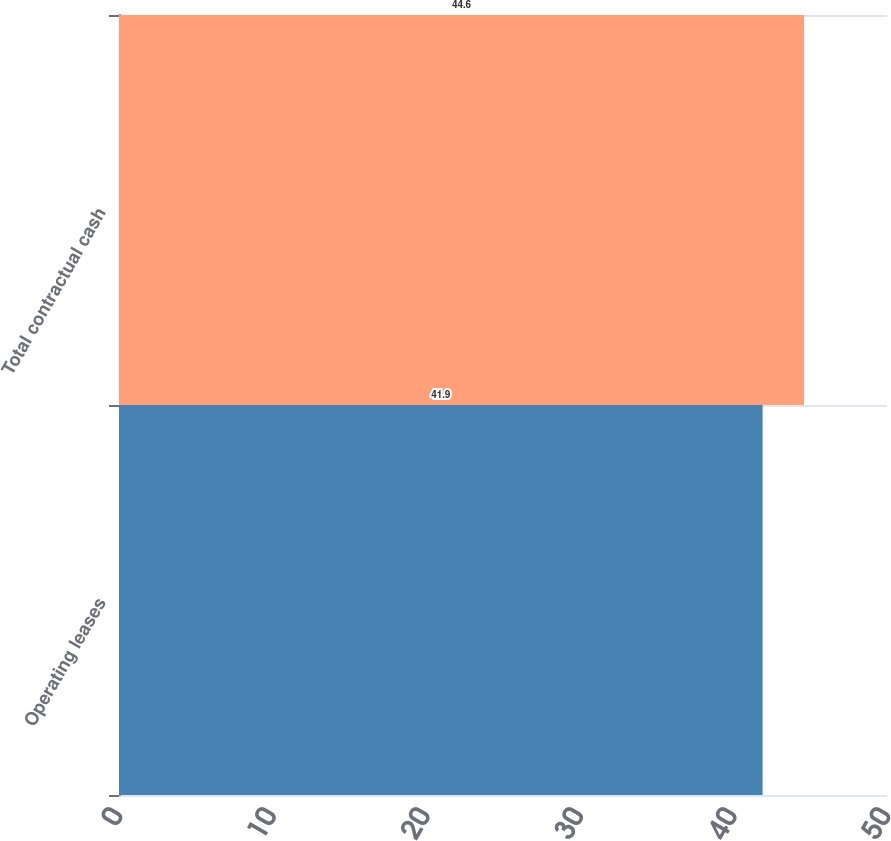Convert chart to OTSL. <chart><loc_0><loc_0><loc_500><loc_500><bar_chart><fcel>Operating leases<fcel>Total contractual cash<nl><fcel>41.9<fcel>44.6<nl></chart> 